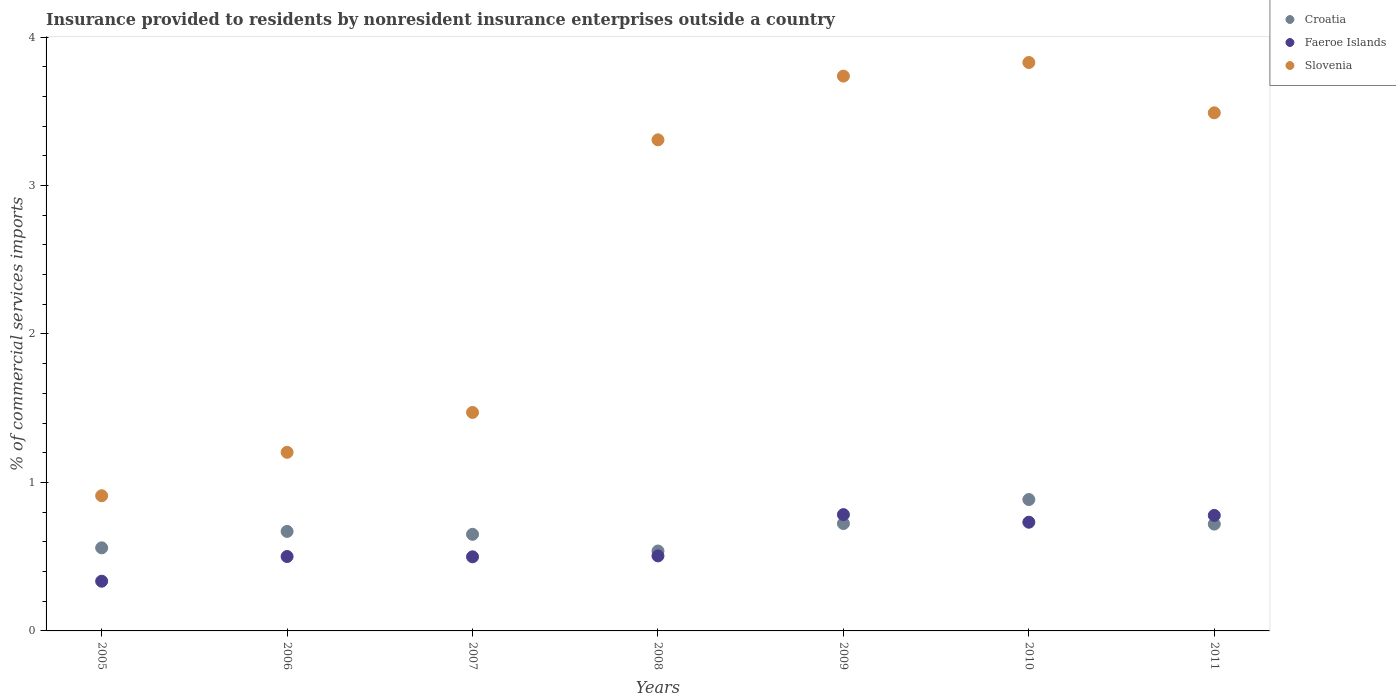How many different coloured dotlines are there?
Ensure brevity in your answer.  3. Is the number of dotlines equal to the number of legend labels?
Make the answer very short. Yes. What is the Insurance provided to residents in Faeroe Islands in 2006?
Offer a very short reply. 0.5. Across all years, what is the maximum Insurance provided to residents in Croatia?
Make the answer very short. 0.88. Across all years, what is the minimum Insurance provided to residents in Croatia?
Provide a short and direct response. 0.54. In which year was the Insurance provided to residents in Faeroe Islands maximum?
Your answer should be compact. 2009. What is the total Insurance provided to residents in Faeroe Islands in the graph?
Your answer should be compact. 4.13. What is the difference between the Insurance provided to residents in Faeroe Islands in 2007 and that in 2011?
Offer a very short reply. -0.28. What is the difference between the Insurance provided to residents in Slovenia in 2007 and the Insurance provided to residents in Croatia in 2008?
Ensure brevity in your answer.  0.93. What is the average Insurance provided to residents in Slovenia per year?
Make the answer very short. 2.56. In the year 2009, what is the difference between the Insurance provided to residents in Croatia and Insurance provided to residents in Faeroe Islands?
Provide a short and direct response. -0.06. What is the ratio of the Insurance provided to residents in Faeroe Islands in 2005 to that in 2008?
Provide a succinct answer. 0.66. Is the difference between the Insurance provided to residents in Croatia in 2007 and 2010 greater than the difference between the Insurance provided to residents in Faeroe Islands in 2007 and 2010?
Make the answer very short. No. What is the difference between the highest and the second highest Insurance provided to residents in Faeroe Islands?
Provide a short and direct response. 0.01. What is the difference between the highest and the lowest Insurance provided to residents in Slovenia?
Ensure brevity in your answer.  2.92. In how many years, is the Insurance provided to residents in Faeroe Islands greater than the average Insurance provided to residents in Faeroe Islands taken over all years?
Your answer should be compact. 3. Is the sum of the Insurance provided to residents in Slovenia in 2009 and 2010 greater than the maximum Insurance provided to residents in Faeroe Islands across all years?
Provide a succinct answer. Yes. Is it the case that in every year, the sum of the Insurance provided to residents in Slovenia and Insurance provided to residents in Croatia  is greater than the Insurance provided to residents in Faeroe Islands?
Ensure brevity in your answer.  Yes. How many dotlines are there?
Give a very brief answer. 3. Does the graph contain any zero values?
Your answer should be very brief. No. Does the graph contain grids?
Provide a succinct answer. No. How many legend labels are there?
Offer a very short reply. 3. What is the title of the graph?
Your answer should be very brief. Insurance provided to residents by nonresident insurance enterprises outside a country. What is the label or title of the Y-axis?
Your answer should be very brief. % of commercial services imports. What is the % of commercial services imports of Croatia in 2005?
Offer a terse response. 0.56. What is the % of commercial services imports in Faeroe Islands in 2005?
Make the answer very short. 0.33. What is the % of commercial services imports in Slovenia in 2005?
Provide a short and direct response. 0.91. What is the % of commercial services imports in Croatia in 2006?
Provide a succinct answer. 0.67. What is the % of commercial services imports in Faeroe Islands in 2006?
Provide a short and direct response. 0.5. What is the % of commercial services imports in Slovenia in 2006?
Your answer should be compact. 1.2. What is the % of commercial services imports in Croatia in 2007?
Provide a succinct answer. 0.65. What is the % of commercial services imports in Faeroe Islands in 2007?
Keep it short and to the point. 0.5. What is the % of commercial services imports of Slovenia in 2007?
Your answer should be very brief. 1.47. What is the % of commercial services imports in Croatia in 2008?
Provide a short and direct response. 0.54. What is the % of commercial services imports of Faeroe Islands in 2008?
Your answer should be very brief. 0.51. What is the % of commercial services imports of Slovenia in 2008?
Provide a short and direct response. 3.31. What is the % of commercial services imports of Croatia in 2009?
Ensure brevity in your answer.  0.72. What is the % of commercial services imports in Faeroe Islands in 2009?
Offer a very short reply. 0.78. What is the % of commercial services imports in Slovenia in 2009?
Offer a terse response. 3.74. What is the % of commercial services imports in Croatia in 2010?
Provide a succinct answer. 0.88. What is the % of commercial services imports of Faeroe Islands in 2010?
Ensure brevity in your answer.  0.73. What is the % of commercial services imports of Slovenia in 2010?
Make the answer very short. 3.83. What is the % of commercial services imports of Croatia in 2011?
Ensure brevity in your answer.  0.72. What is the % of commercial services imports of Faeroe Islands in 2011?
Offer a very short reply. 0.78. What is the % of commercial services imports in Slovenia in 2011?
Your response must be concise. 3.49. Across all years, what is the maximum % of commercial services imports of Croatia?
Your answer should be compact. 0.88. Across all years, what is the maximum % of commercial services imports in Faeroe Islands?
Provide a short and direct response. 0.78. Across all years, what is the maximum % of commercial services imports in Slovenia?
Your answer should be compact. 3.83. Across all years, what is the minimum % of commercial services imports in Croatia?
Your response must be concise. 0.54. Across all years, what is the minimum % of commercial services imports in Faeroe Islands?
Offer a very short reply. 0.33. Across all years, what is the minimum % of commercial services imports in Slovenia?
Make the answer very short. 0.91. What is the total % of commercial services imports of Croatia in the graph?
Offer a very short reply. 4.75. What is the total % of commercial services imports in Faeroe Islands in the graph?
Provide a succinct answer. 4.13. What is the total % of commercial services imports in Slovenia in the graph?
Offer a very short reply. 17.95. What is the difference between the % of commercial services imports of Croatia in 2005 and that in 2006?
Offer a very short reply. -0.11. What is the difference between the % of commercial services imports in Faeroe Islands in 2005 and that in 2006?
Give a very brief answer. -0.17. What is the difference between the % of commercial services imports in Slovenia in 2005 and that in 2006?
Offer a terse response. -0.29. What is the difference between the % of commercial services imports of Croatia in 2005 and that in 2007?
Your response must be concise. -0.09. What is the difference between the % of commercial services imports in Faeroe Islands in 2005 and that in 2007?
Your answer should be very brief. -0.16. What is the difference between the % of commercial services imports in Slovenia in 2005 and that in 2007?
Keep it short and to the point. -0.56. What is the difference between the % of commercial services imports of Croatia in 2005 and that in 2008?
Your response must be concise. 0.02. What is the difference between the % of commercial services imports of Faeroe Islands in 2005 and that in 2008?
Provide a succinct answer. -0.17. What is the difference between the % of commercial services imports in Slovenia in 2005 and that in 2008?
Your response must be concise. -2.4. What is the difference between the % of commercial services imports in Croatia in 2005 and that in 2009?
Your response must be concise. -0.16. What is the difference between the % of commercial services imports of Faeroe Islands in 2005 and that in 2009?
Give a very brief answer. -0.45. What is the difference between the % of commercial services imports of Slovenia in 2005 and that in 2009?
Offer a terse response. -2.83. What is the difference between the % of commercial services imports in Croatia in 2005 and that in 2010?
Offer a terse response. -0.33. What is the difference between the % of commercial services imports in Faeroe Islands in 2005 and that in 2010?
Your answer should be very brief. -0.4. What is the difference between the % of commercial services imports of Slovenia in 2005 and that in 2010?
Ensure brevity in your answer.  -2.92. What is the difference between the % of commercial services imports of Croatia in 2005 and that in 2011?
Your answer should be compact. -0.16. What is the difference between the % of commercial services imports of Faeroe Islands in 2005 and that in 2011?
Your answer should be compact. -0.44. What is the difference between the % of commercial services imports in Slovenia in 2005 and that in 2011?
Offer a terse response. -2.58. What is the difference between the % of commercial services imports of Croatia in 2006 and that in 2007?
Give a very brief answer. 0.02. What is the difference between the % of commercial services imports in Faeroe Islands in 2006 and that in 2007?
Your response must be concise. 0. What is the difference between the % of commercial services imports of Slovenia in 2006 and that in 2007?
Ensure brevity in your answer.  -0.27. What is the difference between the % of commercial services imports in Croatia in 2006 and that in 2008?
Offer a very short reply. 0.13. What is the difference between the % of commercial services imports of Faeroe Islands in 2006 and that in 2008?
Make the answer very short. -0. What is the difference between the % of commercial services imports in Slovenia in 2006 and that in 2008?
Make the answer very short. -2.1. What is the difference between the % of commercial services imports of Croatia in 2006 and that in 2009?
Your response must be concise. -0.05. What is the difference between the % of commercial services imports of Faeroe Islands in 2006 and that in 2009?
Offer a terse response. -0.28. What is the difference between the % of commercial services imports of Slovenia in 2006 and that in 2009?
Keep it short and to the point. -2.53. What is the difference between the % of commercial services imports of Croatia in 2006 and that in 2010?
Offer a terse response. -0.21. What is the difference between the % of commercial services imports of Faeroe Islands in 2006 and that in 2010?
Offer a terse response. -0.23. What is the difference between the % of commercial services imports in Slovenia in 2006 and that in 2010?
Offer a very short reply. -2.63. What is the difference between the % of commercial services imports in Croatia in 2006 and that in 2011?
Make the answer very short. -0.05. What is the difference between the % of commercial services imports of Faeroe Islands in 2006 and that in 2011?
Offer a very short reply. -0.28. What is the difference between the % of commercial services imports of Slovenia in 2006 and that in 2011?
Your response must be concise. -2.29. What is the difference between the % of commercial services imports of Croatia in 2007 and that in 2008?
Give a very brief answer. 0.11. What is the difference between the % of commercial services imports in Faeroe Islands in 2007 and that in 2008?
Offer a terse response. -0.01. What is the difference between the % of commercial services imports of Slovenia in 2007 and that in 2008?
Make the answer very short. -1.84. What is the difference between the % of commercial services imports in Croatia in 2007 and that in 2009?
Offer a very short reply. -0.07. What is the difference between the % of commercial services imports in Faeroe Islands in 2007 and that in 2009?
Provide a succinct answer. -0.28. What is the difference between the % of commercial services imports in Slovenia in 2007 and that in 2009?
Your response must be concise. -2.27. What is the difference between the % of commercial services imports of Croatia in 2007 and that in 2010?
Your answer should be very brief. -0.23. What is the difference between the % of commercial services imports in Faeroe Islands in 2007 and that in 2010?
Your answer should be very brief. -0.23. What is the difference between the % of commercial services imports of Slovenia in 2007 and that in 2010?
Give a very brief answer. -2.36. What is the difference between the % of commercial services imports of Croatia in 2007 and that in 2011?
Ensure brevity in your answer.  -0.07. What is the difference between the % of commercial services imports in Faeroe Islands in 2007 and that in 2011?
Your answer should be compact. -0.28. What is the difference between the % of commercial services imports of Slovenia in 2007 and that in 2011?
Provide a succinct answer. -2.02. What is the difference between the % of commercial services imports of Croatia in 2008 and that in 2009?
Keep it short and to the point. -0.18. What is the difference between the % of commercial services imports in Faeroe Islands in 2008 and that in 2009?
Provide a succinct answer. -0.28. What is the difference between the % of commercial services imports of Slovenia in 2008 and that in 2009?
Make the answer very short. -0.43. What is the difference between the % of commercial services imports in Croatia in 2008 and that in 2010?
Make the answer very short. -0.35. What is the difference between the % of commercial services imports of Faeroe Islands in 2008 and that in 2010?
Ensure brevity in your answer.  -0.23. What is the difference between the % of commercial services imports of Slovenia in 2008 and that in 2010?
Give a very brief answer. -0.52. What is the difference between the % of commercial services imports in Croatia in 2008 and that in 2011?
Ensure brevity in your answer.  -0.18. What is the difference between the % of commercial services imports in Faeroe Islands in 2008 and that in 2011?
Offer a terse response. -0.27. What is the difference between the % of commercial services imports in Slovenia in 2008 and that in 2011?
Your answer should be compact. -0.18. What is the difference between the % of commercial services imports in Croatia in 2009 and that in 2010?
Keep it short and to the point. -0.16. What is the difference between the % of commercial services imports in Faeroe Islands in 2009 and that in 2010?
Offer a very short reply. 0.05. What is the difference between the % of commercial services imports of Slovenia in 2009 and that in 2010?
Your answer should be very brief. -0.09. What is the difference between the % of commercial services imports of Croatia in 2009 and that in 2011?
Keep it short and to the point. 0. What is the difference between the % of commercial services imports of Faeroe Islands in 2009 and that in 2011?
Offer a terse response. 0.01. What is the difference between the % of commercial services imports of Slovenia in 2009 and that in 2011?
Provide a succinct answer. 0.25. What is the difference between the % of commercial services imports of Croatia in 2010 and that in 2011?
Your response must be concise. 0.17. What is the difference between the % of commercial services imports of Faeroe Islands in 2010 and that in 2011?
Keep it short and to the point. -0.05. What is the difference between the % of commercial services imports of Slovenia in 2010 and that in 2011?
Keep it short and to the point. 0.34. What is the difference between the % of commercial services imports of Croatia in 2005 and the % of commercial services imports of Faeroe Islands in 2006?
Make the answer very short. 0.06. What is the difference between the % of commercial services imports in Croatia in 2005 and the % of commercial services imports in Slovenia in 2006?
Your answer should be compact. -0.64. What is the difference between the % of commercial services imports of Faeroe Islands in 2005 and the % of commercial services imports of Slovenia in 2006?
Make the answer very short. -0.87. What is the difference between the % of commercial services imports of Croatia in 2005 and the % of commercial services imports of Faeroe Islands in 2007?
Give a very brief answer. 0.06. What is the difference between the % of commercial services imports in Croatia in 2005 and the % of commercial services imports in Slovenia in 2007?
Make the answer very short. -0.91. What is the difference between the % of commercial services imports in Faeroe Islands in 2005 and the % of commercial services imports in Slovenia in 2007?
Keep it short and to the point. -1.14. What is the difference between the % of commercial services imports of Croatia in 2005 and the % of commercial services imports of Faeroe Islands in 2008?
Your answer should be compact. 0.05. What is the difference between the % of commercial services imports in Croatia in 2005 and the % of commercial services imports in Slovenia in 2008?
Your answer should be very brief. -2.75. What is the difference between the % of commercial services imports in Faeroe Islands in 2005 and the % of commercial services imports in Slovenia in 2008?
Your answer should be very brief. -2.97. What is the difference between the % of commercial services imports of Croatia in 2005 and the % of commercial services imports of Faeroe Islands in 2009?
Your answer should be compact. -0.22. What is the difference between the % of commercial services imports in Croatia in 2005 and the % of commercial services imports in Slovenia in 2009?
Offer a very short reply. -3.18. What is the difference between the % of commercial services imports of Faeroe Islands in 2005 and the % of commercial services imports of Slovenia in 2009?
Your answer should be very brief. -3.4. What is the difference between the % of commercial services imports in Croatia in 2005 and the % of commercial services imports in Faeroe Islands in 2010?
Your answer should be compact. -0.17. What is the difference between the % of commercial services imports in Croatia in 2005 and the % of commercial services imports in Slovenia in 2010?
Your answer should be very brief. -3.27. What is the difference between the % of commercial services imports in Faeroe Islands in 2005 and the % of commercial services imports in Slovenia in 2010?
Ensure brevity in your answer.  -3.49. What is the difference between the % of commercial services imports of Croatia in 2005 and the % of commercial services imports of Faeroe Islands in 2011?
Offer a very short reply. -0.22. What is the difference between the % of commercial services imports of Croatia in 2005 and the % of commercial services imports of Slovenia in 2011?
Offer a very short reply. -2.93. What is the difference between the % of commercial services imports of Faeroe Islands in 2005 and the % of commercial services imports of Slovenia in 2011?
Make the answer very short. -3.15. What is the difference between the % of commercial services imports of Croatia in 2006 and the % of commercial services imports of Faeroe Islands in 2007?
Your answer should be very brief. 0.17. What is the difference between the % of commercial services imports of Croatia in 2006 and the % of commercial services imports of Slovenia in 2007?
Your response must be concise. -0.8. What is the difference between the % of commercial services imports of Faeroe Islands in 2006 and the % of commercial services imports of Slovenia in 2007?
Give a very brief answer. -0.97. What is the difference between the % of commercial services imports in Croatia in 2006 and the % of commercial services imports in Faeroe Islands in 2008?
Provide a short and direct response. 0.16. What is the difference between the % of commercial services imports of Croatia in 2006 and the % of commercial services imports of Slovenia in 2008?
Provide a succinct answer. -2.64. What is the difference between the % of commercial services imports in Faeroe Islands in 2006 and the % of commercial services imports in Slovenia in 2008?
Make the answer very short. -2.81. What is the difference between the % of commercial services imports of Croatia in 2006 and the % of commercial services imports of Faeroe Islands in 2009?
Offer a terse response. -0.11. What is the difference between the % of commercial services imports in Croatia in 2006 and the % of commercial services imports in Slovenia in 2009?
Your answer should be compact. -3.07. What is the difference between the % of commercial services imports of Faeroe Islands in 2006 and the % of commercial services imports of Slovenia in 2009?
Keep it short and to the point. -3.24. What is the difference between the % of commercial services imports of Croatia in 2006 and the % of commercial services imports of Faeroe Islands in 2010?
Keep it short and to the point. -0.06. What is the difference between the % of commercial services imports of Croatia in 2006 and the % of commercial services imports of Slovenia in 2010?
Your answer should be compact. -3.16. What is the difference between the % of commercial services imports in Faeroe Islands in 2006 and the % of commercial services imports in Slovenia in 2010?
Your answer should be very brief. -3.33. What is the difference between the % of commercial services imports of Croatia in 2006 and the % of commercial services imports of Faeroe Islands in 2011?
Offer a terse response. -0.11. What is the difference between the % of commercial services imports of Croatia in 2006 and the % of commercial services imports of Slovenia in 2011?
Provide a short and direct response. -2.82. What is the difference between the % of commercial services imports in Faeroe Islands in 2006 and the % of commercial services imports in Slovenia in 2011?
Ensure brevity in your answer.  -2.99. What is the difference between the % of commercial services imports in Croatia in 2007 and the % of commercial services imports in Faeroe Islands in 2008?
Give a very brief answer. 0.15. What is the difference between the % of commercial services imports of Croatia in 2007 and the % of commercial services imports of Slovenia in 2008?
Offer a very short reply. -2.66. What is the difference between the % of commercial services imports of Faeroe Islands in 2007 and the % of commercial services imports of Slovenia in 2008?
Ensure brevity in your answer.  -2.81. What is the difference between the % of commercial services imports in Croatia in 2007 and the % of commercial services imports in Faeroe Islands in 2009?
Your answer should be compact. -0.13. What is the difference between the % of commercial services imports in Croatia in 2007 and the % of commercial services imports in Slovenia in 2009?
Your answer should be very brief. -3.09. What is the difference between the % of commercial services imports in Faeroe Islands in 2007 and the % of commercial services imports in Slovenia in 2009?
Give a very brief answer. -3.24. What is the difference between the % of commercial services imports of Croatia in 2007 and the % of commercial services imports of Faeroe Islands in 2010?
Your response must be concise. -0.08. What is the difference between the % of commercial services imports in Croatia in 2007 and the % of commercial services imports in Slovenia in 2010?
Ensure brevity in your answer.  -3.18. What is the difference between the % of commercial services imports in Faeroe Islands in 2007 and the % of commercial services imports in Slovenia in 2010?
Provide a succinct answer. -3.33. What is the difference between the % of commercial services imports in Croatia in 2007 and the % of commercial services imports in Faeroe Islands in 2011?
Give a very brief answer. -0.13. What is the difference between the % of commercial services imports in Croatia in 2007 and the % of commercial services imports in Slovenia in 2011?
Offer a very short reply. -2.84. What is the difference between the % of commercial services imports of Faeroe Islands in 2007 and the % of commercial services imports of Slovenia in 2011?
Your answer should be compact. -2.99. What is the difference between the % of commercial services imports of Croatia in 2008 and the % of commercial services imports of Faeroe Islands in 2009?
Give a very brief answer. -0.25. What is the difference between the % of commercial services imports of Croatia in 2008 and the % of commercial services imports of Slovenia in 2009?
Give a very brief answer. -3.2. What is the difference between the % of commercial services imports of Faeroe Islands in 2008 and the % of commercial services imports of Slovenia in 2009?
Keep it short and to the point. -3.23. What is the difference between the % of commercial services imports in Croatia in 2008 and the % of commercial services imports in Faeroe Islands in 2010?
Offer a terse response. -0.19. What is the difference between the % of commercial services imports of Croatia in 2008 and the % of commercial services imports of Slovenia in 2010?
Offer a very short reply. -3.29. What is the difference between the % of commercial services imports of Faeroe Islands in 2008 and the % of commercial services imports of Slovenia in 2010?
Offer a very short reply. -3.32. What is the difference between the % of commercial services imports of Croatia in 2008 and the % of commercial services imports of Faeroe Islands in 2011?
Ensure brevity in your answer.  -0.24. What is the difference between the % of commercial services imports of Croatia in 2008 and the % of commercial services imports of Slovenia in 2011?
Provide a short and direct response. -2.95. What is the difference between the % of commercial services imports of Faeroe Islands in 2008 and the % of commercial services imports of Slovenia in 2011?
Keep it short and to the point. -2.98. What is the difference between the % of commercial services imports of Croatia in 2009 and the % of commercial services imports of Faeroe Islands in 2010?
Your answer should be compact. -0.01. What is the difference between the % of commercial services imports of Croatia in 2009 and the % of commercial services imports of Slovenia in 2010?
Provide a short and direct response. -3.11. What is the difference between the % of commercial services imports of Faeroe Islands in 2009 and the % of commercial services imports of Slovenia in 2010?
Your answer should be compact. -3.04. What is the difference between the % of commercial services imports of Croatia in 2009 and the % of commercial services imports of Faeroe Islands in 2011?
Provide a short and direct response. -0.05. What is the difference between the % of commercial services imports in Croatia in 2009 and the % of commercial services imports in Slovenia in 2011?
Offer a very short reply. -2.77. What is the difference between the % of commercial services imports of Faeroe Islands in 2009 and the % of commercial services imports of Slovenia in 2011?
Ensure brevity in your answer.  -2.71. What is the difference between the % of commercial services imports of Croatia in 2010 and the % of commercial services imports of Faeroe Islands in 2011?
Your response must be concise. 0.11. What is the difference between the % of commercial services imports of Croatia in 2010 and the % of commercial services imports of Slovenia in 2011?
Keep it short and to the point. -2.6. What is the difference between the % of commercial services imports in Faeroe Islands in 2010 and the % of commercial services imports in Slovenia in 2011?
Ensure brevity in your answer.  -2.76. What is the average % of commercial services imports of Croatia per year?
Make the answer very short. 0.68. What is the average % of commercial services imports of Faeroe Islands per year?
Make the answer very short. 0.59. What is the average % of commercial services imports in Slovenia per year?
Your response must be concise. 2.56. In the year 2005, what is the difference between the % of commercial services imports of Croatia and % of commercial services imports of Faeroe Islands?
Offer a very short reply. 0.22. In the year 2005, what is the difference between the % of commercial services imports of Croatia and % of commercial services imports of Slovenia?
Your response must be concise. -0.35. In the year 2005, what is the difference between the % of commercial services imports in Faeroe Islands and % of commercial services imports in Slovenia?
Ensure brevity in your answer.  -0.58. In the year 2006, what is the difference between the % of commercial services imports in Croatia and % of commercial services imports in Faeroe Islands?
Offer a very short reply. 0.17. In the year 2006, what is the difference between the % of commercial services imports of Croatia and % of commercial services imports of Slovenia?
Provide a short and direct response. -0.53. In the year 2006, what is the difference between the % of commercial services imports in Faeroe Islands and % of commercial services imports in Slovenia?
Ensure brevity in your answer.  -0.7. In the year 2007, what is the difference between the % of commercial services imports in Croatia and % of commercial services imports in Faeroe Islands?
Provide a succinct answer. 0.15. In the year 2007, what is the difference between the % of commercial services imports of Croatia and % of commercial services imports of Slovenia?
Offer a terse response. -0.82. In the year 2007, what is the difference between the % of commercial services imports in Faeroe Islands and % of commercial services imports in Slovenia?
Give a very brief answer. -0.97. In the year 2008, what is the difference between the % of commercial services imports in Croatia and % of commercial services imports in Faeroe Islands?
Make the answer very short. 0.03. In the year 2008, what is the difference between the % of commercial services imports in Croatia and % of commercial services imports in Slovenia?
Provide a short and direct response. -2.77. In the year 2008, what is the difference between the % of commercial services imports of Faeroe Islands and % of commercial services imports of Slovenia?
Make the answer very short. -2.8. In the year 2009, what is the difference between the % of commercial services imports of Croatia and % of commercial services imports of Faeroe Islands?
Provide a succinct answer. -0.06. In the year 2009, what is the difference between the % of commercial services imports in Croatia and % of commercial services imports in Slovenia?
Make the answer very short. -3.01. In the year 2009, what is the difference between the % of commercial services imports in Faeroe Islands and % of commercial services imports in Slovenia?
Provide a short and direct response. -2.95. In the year 2010, what is the difference between the % of commercial services imports of Croatia and % of commercial services imports of Faeroe Islands?
Your answer should be very brief. 0.15. In the year 2010, what is the difference between the % of commercial services imports of Croatia and % of commercial services imports of Slovenia?
Offer a very short reply. -2.94. In the year 2010, what is the difference between the % of commercial services imports in Faeroe Islands and % of commercial services imports in Slovenia?
Ensure brevity in your answer.  -3.1. In the year 2011, what is the difference between the % of commercial services imports of Croatia and % of commercial services imports of Faeroe Islands?
Give a very brief answer. -0.06. In the year 2011, what is the difference between the % of commercial services imports in Croatia and % of commercial services imports in Slovenia?
Your response must be concise. -2.77. In the year 2011, what is the difference between the % of commercial services imports of Faeroe Islands and % of commercial services imports of Slovenia?
Your response must be concise. -2.71. What is the ratio of the % of commercial services imports in Croatia in 2005 to that in 2006?
Keep it short and to the point. 0.83. What is the ratio of the % of commercial services imports in Faeroe Islands in 2005 to that in 2006?
Your answer should be compact. 0.67. What is the ratio of the % of commercial services imports of Slovenia in 2005 to that in 2006?
Make the answer very short. 0.76. What is the ratio of the % of commercial services imports of Croatia in 2005 to that in 2007?
Offer a very short reply. 0.86. What is the ratio of the % of commercial services imports of Faeroe Islands in 2005 to that in 2007?
Ensure brevity in your answer.  0.67. What is the ratio of the % of commercial services imports in Slovenia in 2005 to that in 2007?
Provide a short and direct response. 0.62. What is the ratio of the % of commercial services imports of Croatia in 2005 to that in 2008?
Provide a short and direct response. 1.04. What is the ratio of the % of commercial services imports of Faeroe Islands in 2005 to that in 2008?
Give a very brief answer. 0.66. What is the ratio of the % of commercial services imports of Slovenia in 2005 to that in 2008?
Your response must be concise. 0.28. What is the ratio of the % of commercial services imports of Croatia in 2005 to that in 2009?
Your answer should be compact. 0.77. What is the ratio of the % of commercial services imports in Faeroe Islands in 2005 to that in 2009?
Your answer should be compact. 0.43. What is the ratio of the % of commercial services imports of Slovenia in 2005 to that in 2009?
Ensure brevity in your answer.  0.24. What is the ratio of the % of commercial services imports in Croatia in 2005 to that in 2010?
Give a very brief answer. 0.63. What is the ratio of the % of commercial services imports in Faeroe Islands in 2005 to that in 2010?
Keep it short and to the point. 0.46. What is the ratio of the % of commercial services imports in Slovenia in 2005 to that in 2010?
Provide a succinct answer. 0.24. What is the ratio of the % of commercial services imports of Faeroe Islands in 2005 to that in 2011?
Ensure brevity in your answer.  0.43. What is the ratio of the % of commercial services imports in Slovenia in 2005 to that in 2011?
Offer a very short reply. 0.26. What is the ratio of the % of commercial services imports of Croatia in 2006 to that in 2007?
Your answer should be compact. 1.03. What is the ratio of the % of commercial services imports in Slovenia in 2006 to that in 2007?
Ensure brevity in your answer.  0.82. What is the ratio of the % of commercial services imports of Croatia in 2006 to that in 2008?
Give a very brief answer. 1.25. What is the ratio of the % of commercial services imports of Slovenia in 2006 to that in 2008?
Your answer should be compact. 0.36. What is the ratio of the % of commercial services imports in Croatia in 2006 to that in 2009?
Ensure brevity in your answer.  0.93. What is the ratio of the % of commercial services imports of Faeroe Islands in 2006 to that in 2009?
Provide a succinct answer. 0.64. What is the ratio of the % of commercial services imports in Slovenia in 2006 to that in 2009?
Give a very brief answer. 0.32. What is the ratio of the % of commercial services imports in Croatia in 2006 to that in 2010?
Offer a terse response. 0.76. What is the ratio of the % of commercial services imports of Faeroe Islands in 2006 to that in 2010?
Offer a very short reply. 0.68. What is the ratio of the % of commercial services imports in Slovenia in 2006 to that in 2010?
Offer a terse response. 0.31. What is the ratio of the % of commercial services imports of Croatia in 2006 to that in 2011?
Your answer should be compact. 0.93. What is the ratio of the % of commercial services imports of Faeroe Islands in 2006 to that in 2011?
Offer a terse response. 0.64. What is the ratio of the % of commercial services imports of Slovenia in 2006 to that in 2011?
Offer a terse response. 0.34. What is the ratio of the % of commercial services imports in Croatia in 2007 to that in 2008?
Ensure brevity in your answer.  1.21. What is the ratio of the % of commercial services imports in Faeroe Islands in 2007 to that in 2008?
Your response must be concise. 0.99. What is the ratio of the % of commercial services imports of Slovenia in 2007 to that in 2008?
Make the answer very short. 0.44. What is the ratio of the % of commercial services imports of Croatia in 2007 to that in 2009?
Your answer should be compact. 0.9. What is the ratio of the % of commercial services imports in Faeroe Islands in 2007 to that in 2009?
Give a very brief answer. 0.64. What is the ratio of the % of commercial services imports in Slovenia in 2007 to that in 2009?
Make the answer very short. 0.39. What is the ratio of the % of commercial services imports in Croatia in 2007 to that in 2010?
Provide a succinct answer. 0.74. What is the ratio of the % of commercial services imports of Faeroe Islands in 2007 to that in 2010?
Provide a succinct answer. 0.68. What is the ratio of the % of commercial services imports in Slovenia in 2007 to that in 2010?
Make the answer very short. 0.38. What is the ratio of the % of commercial services imports in Croatia in 2007 to that in 2011?
Offer a terse response. 0.9. What is the ratio of the % of commercial services imports of Faeroe Islands in 2007 to that in 2011?
Your answer should be very brief. 0.64. What is the ratio of the % of commercial services imports of Slovenia in 2007 to that in 2011?
Ensure brevity in your answer.  0.42. What is the ratio of the % of commercial services imports in Croatia in 2008 to that in 2009?
Offer a very short reply. 0.74. What is the ratio of the % of commercial services imports of Faeroe Islands in 2008 to that in 2009?
Provide a short and direct response. 0.65. What is the ratio of the % of commercial services imports of Slovenia in 2008 to that in 2009?
Keep it short and to the point. 0.89. What is the ratio of the % of commercial services imports in Croatia in 2008 to that in 2010?
Provide a short and direct response. 0.61. What is the ratio of the % of commercial services imports in Faeroe Islands in 2008 to that in 2010?
Offer a very short reply. 0.69. What is the ratio of the % of commercial services imports of Slovenia in 2008 to that in 2010?
Keep it short and to the point. 0.86. What is the ratio of the % of commercial services imports of Croatia in 2008 to that in 2011?
Your response must be concise. 0.75. What is the ratio of the % of commercial services imports in Faeroe Islands in 2008 to that in 2011?
Your response must be concise. 0.65. What is the ratio of the % of commercial services imports in Slovenia in 2008 to that in 2011?
Your answer should be very brief. 0.95. What is the ratio of the % of commercial services imports of Croatia in 2009 to that in 2010?
Provide a succinct answer. 0.82. What is the ratio of the % of commercial services imports of Faeroe Islands in 2009 to that in 2010?
Ensure brevity in your answer.  1.07. What is the ratio of the % of commercial services imports of Slovenia in 2009 to that in 2010?
Make the answer very short. 0.98. What is the ratio of the % of commercial services imports in Faeroe Islands in 2009 to that in 2011?
Provide a short and direct response. 1.01. What is the ratio of the % of commercial services imports in Slovenia in 2009 to that in 2011?
Make the answer very short. 1.07. What is the ratio of the % of commercial services imports of Croatia in 2010 to that in 2011?
Offer a very short reply. 1.23. What is the ratio of the % of commercial services imports in Slovenia in 2010 to that in 2011?
Give a very brief answer. 1.1. What is the difference between the highest and the second highest % of commercial services imports of Croatia?
Your response must be concise. 0.16. What is the difference between the highest and the second highest % of commercial services imports of Faeroe Islands?
Ensure brevity in your answer.  0.01. What is the difference between the highest and the second highest % of commercial services imports in Slovenia?
Offer a very short reply. 0.09. What is the difference between the highest and the lowest % of commercial services imports in Croatia?
Offer a very short reply. 0.35. What is the difference between the highest and the lowest % of commercial services imports of Faeroe Islands?
Offer a very short reply. 0.45. What is the difference between the highest and the lowest % of commercial services imports of Slovenia?
Make the answer very short. 2.92. 